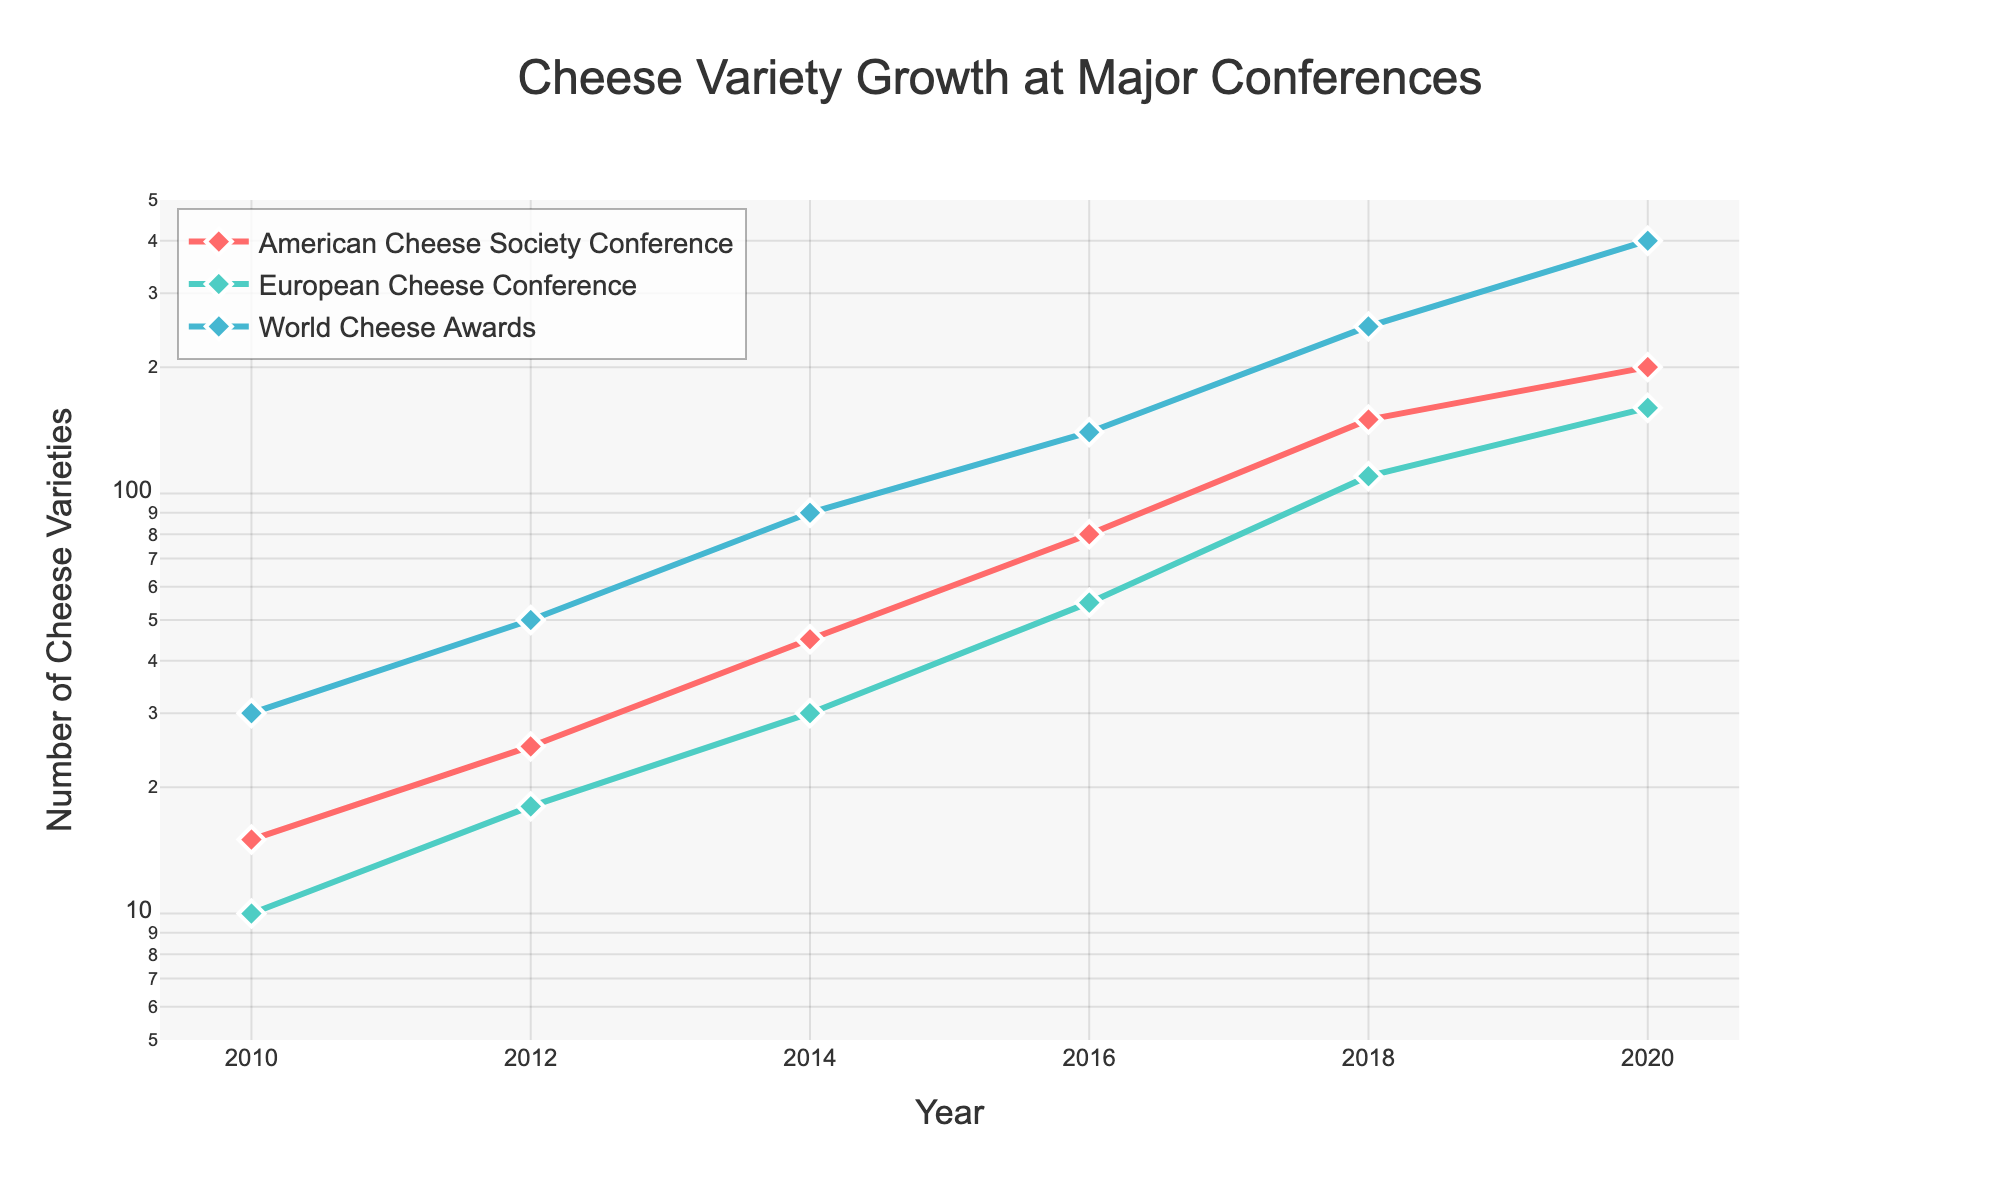What is the title of the plot? The title of the plot is found at the top center of the figure. It reads "Cheese Variety Growth at Major Conferences".
Answer: Cheese Variety Growth at Major Conferences Which conference had the highest number of cheese varieties in 2020? By looking at the y-axis for the year 2020, the "World Cheese Awards" had the highest number of cheese varieties, with 400 varieties.
Answer: World Cheese Awards How many data points are there for the "American Cheese Society Conference"? Each marker on the "American Cheese Society Conference" line represents a data point. There are 6 such markers corresponding to the years 2010, 2012, 2014, 2016, 2018, and 2020.
Answer: 6 Between which two years did the "European Cheese Conference" see the largest increase in the number of cheese varieties? The largest increase can be determined by looking at the differences between consecutive data points. From 2016 to 2018, the number increased from 55 to 110 cheese varieties, the largest year-to-year increase of 55 varieties.
Answer: 2016 to 2018 Compare the growth trend of the "American Cheese Society Conference" with the "World Cheese Awards". Who showed a sharper increase? By examining the slope of the lines, the "World Cheese Awards" shows a steeper increase in cheese varieties over time, indicating a sharper growth trend.
Answer: World Cheese Awards In which year did the conferences first begin to have more than 100 cheese varieties? The first instances of more than 100 cheese varieties occur in 2018 for both the "American Cheese Society Conference" and the "World Cheese Awards".
Answer: 2018 How many cheese varieties were there at the "European Cheese Conference" in 2010? According to the data corresponding to the year 2010, the "European Cheese Conference" had 10 cheese varieties.
Answer: 10 Which conference had the smallest number of cheese varieties recorded in any year, and how many? The smallest number of cheese varieties is recorded by the "European Cheese Conference" with 10 varieties in the year 2010.
Answer: European Cheese Conference, 10 What trend can be observed in the number of cheese varieties across all conferences over the years? There is an overall upward trend in the number of cheese varieties presented at all three conferences over the years. This can be seen as all lines are trending upwards from left to right.
Answer: Upward trend 